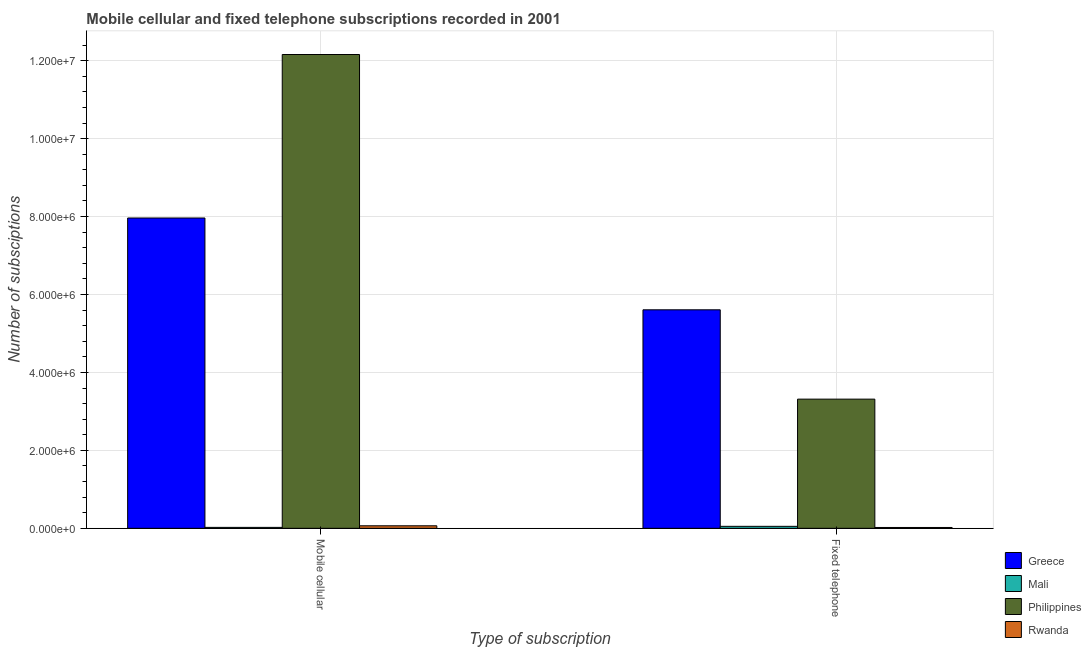Are the number of bars per tick equal to the number of legend labels?
Provide a succinct answer. Yes. How many bars are there on the 1st tick from the right?
Keep it short and to the point. 4. What is the label of the 1st group of bars from the left?
Your answer should be very brief. Mobile cellular. What is the number of mobile cellular subscriptions in Rwanda?
Offer a very short reply. 6.50e+04. Across all countries, what is the maximum number of mobile cellular subscriptions?
Ensure brevity in your answer.  1.22e+07. Across all countries, what is the minimum number of fixed telephone subscriptions?
Give a very brief answer. 2.15e+04. In which country was the number of fixed telephone subscriptions minimum?
Offer a terse response. Rwanda. What is the total number of mobile cellular subscriptions in the graph?
Offer a terse response. 2.02e+07. What is the difference between the number of mobile cellular subscriptions in Mali and that in Rwanda?
Offer a terse response. -4.10e+04. What is the difference between the number of mobile cellular subscriptions in Mali and the number of fixed telephone subscriptions in Greece?
Offer a terse response. -5.58e+06. What is the average number of fixed telephone subscriptions per country?
Give a very brief answer. 2.25e+06. What is the difference between the number of mobile cellular subscriptions and number of fixed telephone subscriptions in Mali?
Give a very brief answer. -2.71e+04. What is the ratio of the number of mobile cellular subscriptions in Rwanda to that in Philippines?
Provide a short and direct response. 0.01. In how many countries, is the number of mobile cellular subscriptions greater than the average number of mobile cellular subscriptions taken over all countries?
Your answer should be very brief. 2. What does the 2nd bar from the left in Fixed telephone represents?
Offer a terse response. Mali. What does the 3rd bar from the right in Mobile cellular represents?
Provide a short and direct response. Mali. How many bars are there?
Provide a short and direct response. 8. What is the difference between two consecutive major ticks on the Y-axis?
Keep it short and to the point. 2.00e+06. Are the values on the major ticks of Y-axis written in scientific E-notation?
Your answer should be compact. Yes. Does the graph contain any zero values?
Keep it short and to the point. No. Does the graph contain grids?
Keep it short and to the point. Yes. How many legend labels are there?
Give a very brief answer. 4. How are the legend labels stacked?
Your answer should be very brief. Vertical. What is the title of the graph?
Your answer should be compact. Mobile cellular and fixed telephone subscriptions recorded in 2001. What is the label or title of the X-axis?
Provide a short and direct response. Type of subscription. What is the label or title of the Y-axis?
Your response must be concise. Number of subsciptions. What is the Number of subsciptions in Greece in Mobile cellular?
Keep it short and to the point. 7.96e+06. What is the Number of subsciptions of Mali in Mobile cellular?
Offer a terse response. 2.40e+04. What is the Number of subsciptions in Philippines in Mobile cellular?
Offer a terse response. 1.22e+07. What is the Number of subsciptions in Rwanda in Mobile cellular?
Ensure brevity in your answer.  6.50e+04. What is the Number of subsciptions in Greece in Fixed telephone?
Provide a short and direct response. 5.61e+06. What is the Number of subsciptions of Mali in Fixed telephone?
Your response must be concise. 5.11e+04. What is the Number of subsciptions in Philippines in Fixed telephone?
Your answer should be compact. 3.32e+06. What is the Number of subsciptions in Rwanda in Fixed telephone?
Provide a short and direct response. 2.15e+04. Across all Type of subscription, what is the maximum Number of subsciptions in Greece?
Offer a terse response. 7.96e+06. Across all Type of subscription, what is the maximum Number of subsciptions of Mali?
Your answer should be compact. 5.11e+04. Across all Type of subscription, what is the maximum Number of subsciptions in Philippines?
Offer a terse response. 1.22e+07. Across all Type of subscription, what is the maximum Number of subsciptions of Rwanda?
Your answer should be compact. 6.50e+04. Across all Type of subscription, what is the minimum Number of subsciptions in Greece?
Your answer should be very brief. 5.61e+06. Across all Type of subscription, what is the minimum Number of subsciptions in Mali?
Offer a very short reply. 2.40e+04. Across all Type of subscription, what is the minimum Number of subsciptions of Philippines?
Provide a short and direct response. 3.32e+06. Across all Type of subscription, what is the minimum Number of subsciptions of Rwanda?
Provide a short and direct response. 2.15e+04. What is the total Number of subsciptions of Greece in the graph?
Keep it short and to the point. 1.36e+07. What is the total Number of subsciptions in Mali in the graph?
Keep it short and to the point. 7.51e+04. What is the total Number of subsciptions in Philippines in the graph?
Provide a succinct answer. 1.55e+07. What is the total Number of subsciptions of Rwanda in the graph?
Your answer should be compact. 8.65e+04. What is the difference between the Number of subsciptions in Greece in Mobile cellular and that in Fixed telephone?
Make the answer very short. 2.36e+06. What is the difference between the Number of subsciptions in Mali in Mobile cellular and that in Fixed telephone?
Your response must be concise. -2.71e+04. What is the difference between the Number of subsciptions of Philippines in Mobile cellular and that in Fixed telephone?
Ensure brevity in your answer.  8.84e+06. What is the difference between the Number of subsciptions of Rwanda in Mobile cellular and that in Fixed telephone?
Your answer should be compact. 4.35e+04. What is the difference between the Number of subsciptions of Greece in Mobile cellular and the Number of subsciptions of Mali in Fixed telephone?
Your response must be concise. 7.91e+06. What is the difference between the Number of subsciptions of Greece in Mobile cellular and the Number of subsciptions of Philippines in Fixed telephone?
Ensure brevity in your answer.  4.65e+06. What is the difference between the Number of subsciptions in Greece in Mobile cellular and the Number of subsciptions in Rwanda in Fixed telephone?
Make the answer very short. 7.94e+06. What is the difference between the Number of subsciptions of Mali in Mobile cellular and the Number of subsciptions of Philippines in Fixed telephone?
Your answer should be very brief. -3.29e+06. What is the difference between the Number of subsciptions of Mali in Mobile cellular and the Number of subsciptions of Rwanda in Fixed telephone?
Provide a short and direct response. 2497. What is the difference between the Number of subsciptions in Philippines in Mobile cellular and the Number of subsciptions in Rwanda in Fixed telephone?
Make the answer very short. 1.21e+07. What is the average Number of subsciptions of Greece per Type of subscription?
Give a very brief answer. 6.79e+06. What is the average Number of subsciptions in Mali per Type of subscription?
Keep it short and to the point. 3.75e+04. What is the average Number of subsciptions in Philippines per Type of subscription?
Your answer should be very brief. 7.74e+06. What is the average Number of subsciptions of Rwanda per Type of subscription?
Ensure brevity in your answer.  4.32e+04. What is the difference between the Number of subsciptions of Greece and Number of subsciptions of Mali in Mobile cellular?
Your answer should be very brief. 7.94e+06. What is the difference between the Number of subsciptions of Greece and Number of subsciptions of Philippines in Mobile cellular?
Make the answer very short. -4.20e+06. What is the difference between the Number of subsciptions in Greece and Number of subsciptions in Rwanda in Mobile cellular?
Your answer should be compact. 7.90e+06. What is the difference between the Number of subsciptions of Mali and Number of subsciptions of Philippines in Mobile cellular?
Provide a short and direct response. -1.21e+07. What is the difference between the Number of subsciptions of Mali and Number of subsciptions of Rwanda in Mobile cellular?
Provide a succinct answer. -4.10e+04. What is the difference between the Number of subsciptions of Philippines and Number of subsciptions of Rwanda in Mobile cellular?
Your answer should be compact. 1.21e+07. What is the difference between the Number of subsciptions of Greece and Number of subsciptions of Mali in Fixed telephone?
Make the answer very short. 5.56e+06. What is the difference between the Number of subsciptions in Greece and Number of subsciptions in Philippines in Fixed telephone?
Make the answer very short. 2.29e+06. What is the difference between the Number of subsciptions of Greece and Number of subsciptions of Rwanda in Fixed telephone?
Make the answer very short. 5.59e+06. What is the difference between the Number of subsciptions of Mali and Number of subsciptions of Philippines in Fixed telephone?
Give a very brief answer. -3.26e+06. What is the difference between the Number of subsciptions in Mali and Number of subsciptions in Rwanda in Fixed telephone?
Offer a terse response. 2.96e+04. What is the difference between the Number of subsciptions in Philippines and Number of subsciptions in Rwanda in Fixed telephone?
Offer a terse response. 3.29e+06. What is the ratio of the Number of subsciptions of Greece in Mobile cellular to that in Fixed telephone?
Offer a very short reply. 1.42. What is the ratio of the Number of subsciptions of Mali in Mobile cellular to that in Fixed telephone?
Provide a short and direct response. 0.47. What is the ratio of the Number of subsciptions of Philippines in Mobile cellular to that in Fixed telephone?
Ensure brevity in your answer.  3.67. What is the ratio of the Number of subsciptions of Rwanda in Mobile cellular to that in Fixed telephone?
Make the answer very short. 3.02. What is the difference between the highest and the second highest Number of subsciptions of Greece?
Make the answer very short. 2.36e+06. What is the difference between the highest and the second highest Number of subsciptions in Mali?
Your answer should be very brief. 2.71e+04. What is the difference between the highest and the second highest Number of subsciptions in Philippines?
Your response must be concise. 8.84e+06. What is the difference between the highest and the second highest Number of subsciptions in Rwanda?
Your answer should be very brief. 4.35e+04. What is the difference between the highest and the lowest Number of subsciptions in Greece?
Offer a very short reply. 2.36e+06. What is the difference between the highest and the lowest Number of subsciptions in Mali?
Ensure brevity in your answer.  2.71e+04. What is the difference between the highest and the lowest Number of subsciptions in Philippines?
Give a very brief answer. 8.84e+06. What is the difference between the highest and the lowest Number of subsciptions in Rwanda?
Your answer should be very brief. 4.35e+04. 